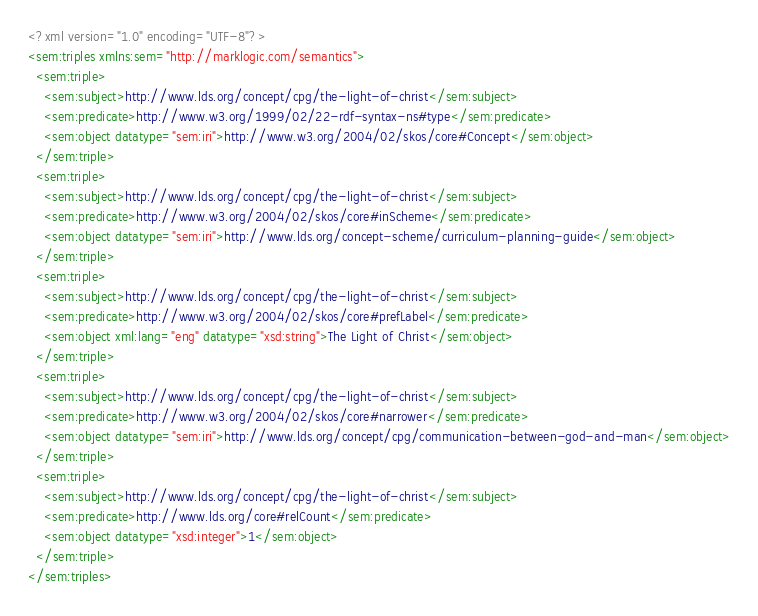Convert code to text. <code><loc_0><loc_0><loc_500><loc_500><_XML_><?xml version="1.0" encoding="UTF-8"?>
<sem:triples xmlns:sem="http://marklogic.com/semantics">
  <sem:triple>
    <sem:subject>http://www.lds.org/concept/cpg/the-light-of-christ</sem:subject>
    <sem:predicate>http://www.w3.org/1999/02/22-rdf-syntax-ns#type</sem:predicate>
    <sem:object datatype="sem:iri">http://www.w3.org/2004/02/skos/core#Concept</sem:object>
  </sem:triple>
  <sem:triple>
    <sem:subject>http://www.lds.org/concept/cpg/the-light-of-christ</sem:subject>
    <sem:predicate>http://www.w3.org/2004/02/skos/core#inScheme</sem:predicate>
    <sem:object datatype="sem:iri">http://www.lds.org/concept-scheme/curriculum-planning-guide</sem:object>
  </sem:triple>
  <sem:triple>
    <sem:subject>http://www.lds.org/concept/cpg/the-light-of-christ</sem:subject>
    <sem:predicate>http://www.w3.org/2004/02/skos/core#prefLabel</sem:predicate>
    <sem:object xml:lang="eng" datatype="xsd:string">The Light of Christ</sem:object>
  </sem:triple>
  <sem:triple>
    <sem:subject>http://www.lds.org/concept/cpg/the-light-of-christ</sem:subject>
    <sem:predicate>http://www.w3.org/2004/02/skos/core#narrower</sem:predicate>
    <sem:object datatype="sem:iri">http://www.lds.org/concept/cpg/communication-between-god-and-man</sem:object>
  </sem:triple>
  <sem:triple>
    <sem:subject>http://www.lds.org/concept/cpg/the-light-of-christ</sem:subject>
    <sem:predicate>http://www.lds.org/core#relCount</sem:predicate>
    <sem:object datatype="xsd:integer">1</sem:object>
  </sem:triple>
</sem:triples>
</code> 